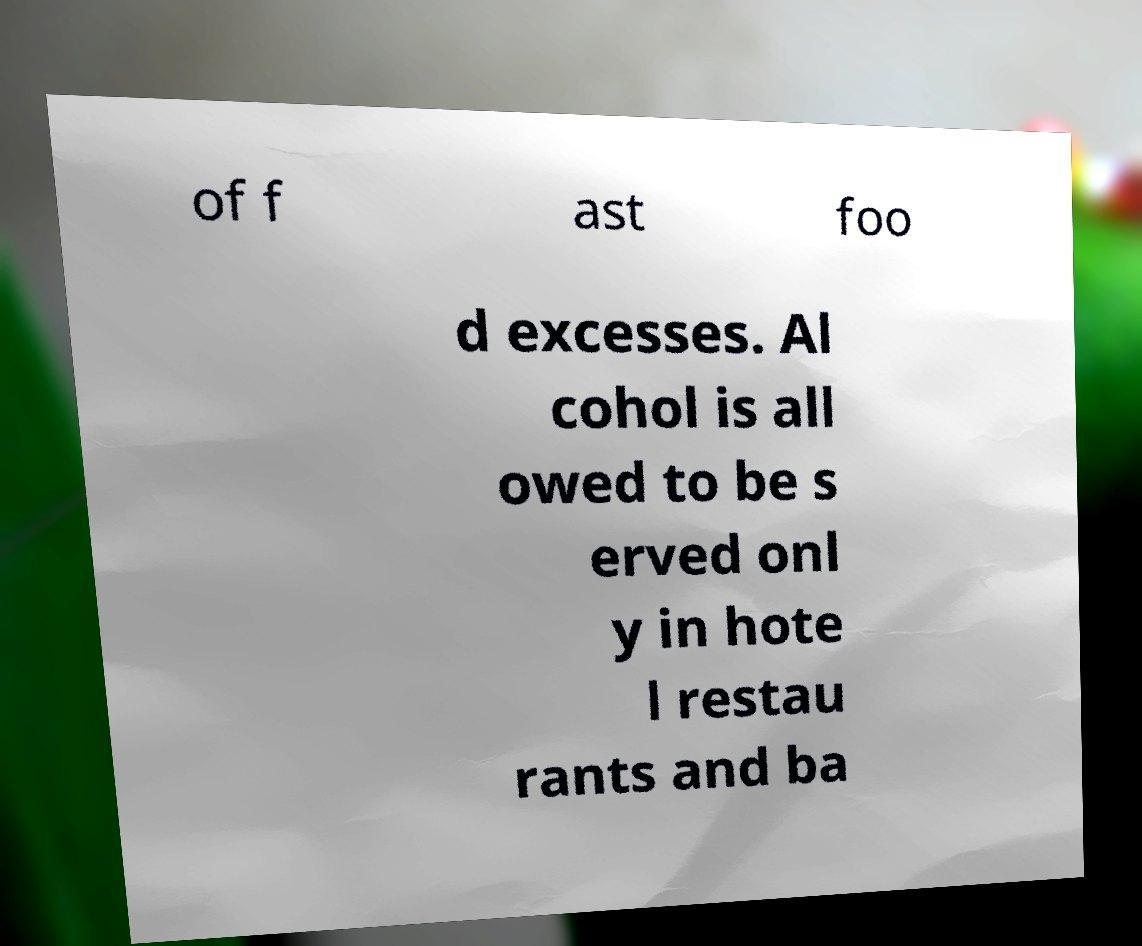Please identify and transcribe the text found in this image. of f ast foo d excesses. Al cohol is all owed to be s erved onl y in hote l restau rants and ba 